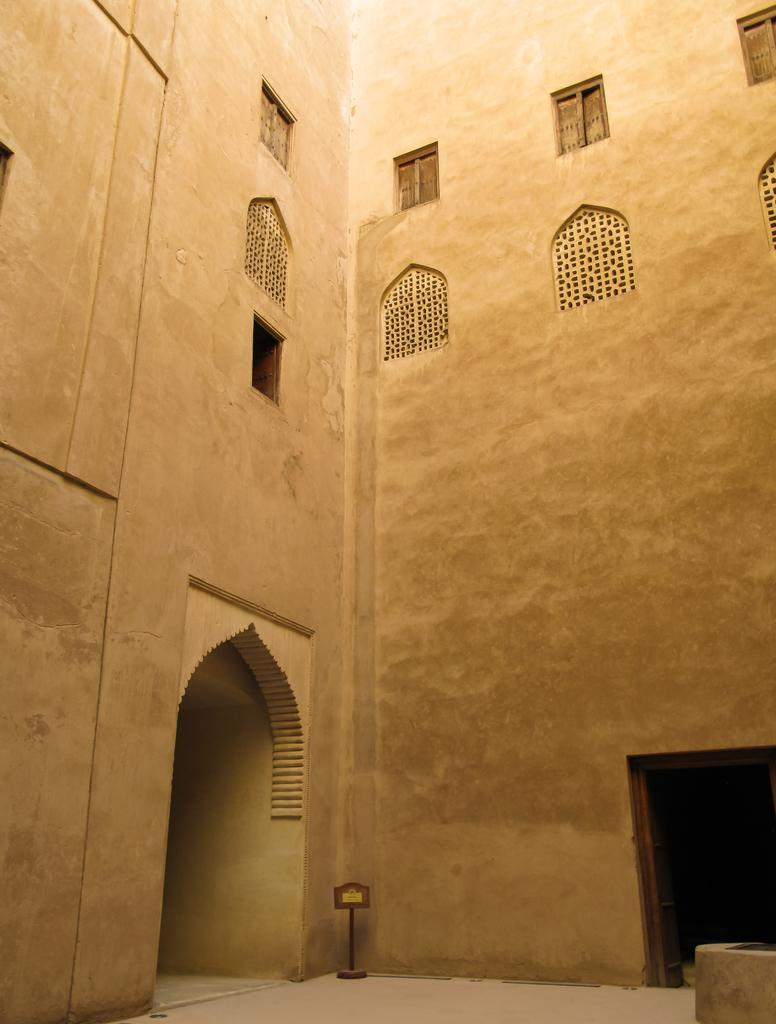What type of structure can be seen in the image? There is a wall in the image. Are there any openings in the wall? Yes, there are windows in the image. What is located at the bottom of the image? There is a board at the bottom of the image. Can you see any fairies flying around the windows in the image? There are no fairies present in the image. Is there a nest visible in the image? There is no nest present in the image. 